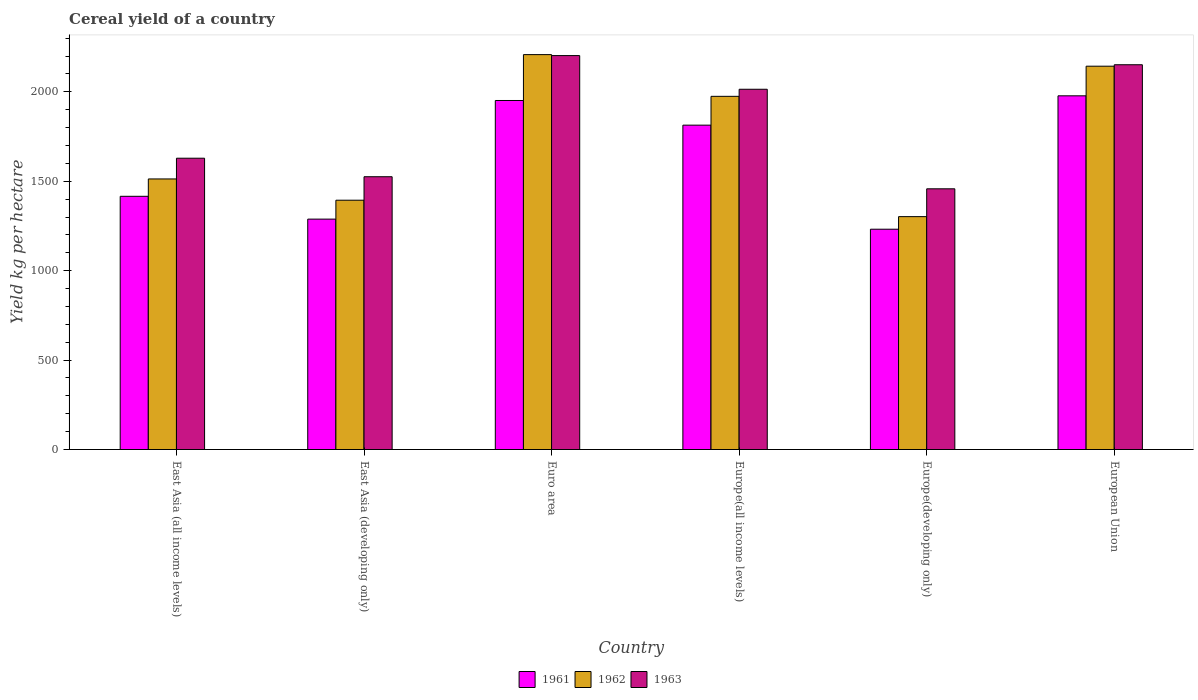How many groups of bars are there?
Provide a succinct answer. 6. How many bars are there on the 2nd tick from the right?
Make the answer very short. 3. What is the label of the 2nd group of bars from the left?
Ensure brevity in your answer.  East Asia (developing only). What is the total cereal yield in 1963 in East Asia (developing only)?
Offer a very short reply. 1525.26. Across all countries, what is the maximum total cereal yield in 1962?
Your answer should be very brief. 2207.97. Across all countries, what is the minimum total cereal yield in 1963?
Ensure brevity in your answer.  1457.68. In which country was the total cereal yield in 1963 minimum?
Provide a succinct answer. Europe(developing only). What is the total total cereal yield in 1962 in the graph?
Make the answer very short. 1.05e+04. What is the difference between the total cereal yield in 1961 in Europe(all income levels) and that in European Union?
Give a very brief answer. -163.96. What is the difference between the total cereal yield in 1961 in Euro area and the total cereal yield in 1963 in East Asia (developing only)?
Keep it short and to the point. 426.25. What is the average total cereal yield in 1962 per country?
Your answer should be compact. 1755.82. What is the difference between the total cereal yield of/in 1963 and total cereal yield of/in 1962 in East Asia (developing only)?
Provide a succinct answer. 131.32. In how many countries, is the total cereal yield in 1962 greater than 200 kg per hectare?
Your response must be concise. 6. What is the ratio of the total cereal yield in 1963 in East Asia (all income levels) to that in Europe(developing only)?
Your answer should be very brief. 1.12. Is the total cereal yield in 1963 in Euro area less than that in European Union?
Your answer should be compact. No. Is the difference between the total cereal yield in 1963 in East Asia (all income levels) and Europe(developing only) greater than the difference between the total cereal yield in 1962 in East Asia (all income levels) and Europe(developing only)?
Provide a short and direct response. No. What is the difference between the highest and the second highest total cereal yield in 1963?
Provide a succinct answer. 188.19. What is the difference between the highest and the lowest total cereal yield in 1961?
Keep it short and to the point. 745.86. Is the sum of the total cereal yield in 1962 in East Asia (all income levels) and Euro area greater than the maximum total cereal yield in 1961 across all countries?
Your answer should be compact. Yes. What does the 3rd bar from the left in Europe(all income levels) represents?
Offer a very short reply. 1963. How many bars are there?
Offer a terse response. 18. How many countries are there in the graph?
Offer a terse response. 6. Are the values on the major ticks of Y-axis written in scientific E-notation?
Make the answer very short. No. Does the graph contain any zero values?
Offer a terse response. No. Where does the legend appear in the graph?
Provide a short and direct response. Bottom center. How many legend labels are there?
Provide a short and direct response. 3. How are the legend labels stacked?
Keep it short and to the point. Horizontal. What is the title of the graph?
Your response must be concise. Cereal yield of a country. What is the label or title of the Y-axis?
Your answer should be compact. Yield kg per hectare. What is the Yield kg per hectare in 1961 in East Asia (all income levels)?
Ensure brevity in your answer.  1415.81. What is the Yield kg per hectare in 1962 in East Asia (all income levels)?
Offer a very short reply. 1512.87. What is the Yield kg per hectare of 1963 in East Asia (all income levels)?
Your response must be concise. 1628.8. What is the Yield kg per hectare of 1961 in East Asia (developing only)?
Make the answer very short. 1288.2. What is the Yield kg per hectare in 1962 in East Asia (developing only)?
Keep it short and to the point. 1393.94. What is the Yield kg per hectare of 1963 in East Asia (developing only)?
Provide a short and direct response. 1525.26. What is the Yield kg per hectare of 1961 in Euro area?
Your response must be concise. 1951.5. What is the Yield kg per hectare in 1962 in Euro area?
Offer a very short reply. 2207.97. What is the Yield kg per hectare in 1963 in Euro area?
Your answer should be very brief. 2202.53. What is the Yield kg per hectare of 1961 in Europe(all income levels)?
Your answer should be compact. 1813.66. What is the Yield kg per hectare of 1962 in Europe(all income levels)?
Make the answer very short. 1974.73. What is the Yield kg per hectare in 1963 in Europe(all income levels)?
Your answer should be compact. 2014.33. What is the Yield kg per hectare of 1961 in Europe(developing only)?
Offer a terse response. 1231.76. What is the Yield kg per hectare in 1962 in Europe(developing only)?
Keep it short and to the point. 1302.16. What is the Yield kg per hectare in 1963 in Europe(developing only)?
Make the answer very short. 1457.68. What is the Yield kg per hectare of 1961 in European Union?
Your response must be concise. 1977.62. What is the Yield kg per hectare in 1962 in European Union?
Your response must be concise. 2143.26. What is the Yield kg per hectare in 1963 in European Union?
Offer a very short reply. 2151.34. Across all countries, what is the maximum Yield kg per hectare in 1961?
Your answer should be very brief. 1977.62. Across all countries, what is the maximum Yield kg per hectare of 1962?
Provide a succinct answer. 2207.97. Across all countries, what is the maximum Yield kg per hectare of 1963?
Your answer should be compact. 2202.53. Across all countries, what is the minimum Yield kg per hectare of 1961?
Keep it short and to the point. 1231.76. Across all countries, what is the minimum Yield kg per hectare in 1962?
Give a very brief answer. 1302.16. Across all countries, what is the minimum Yield kg per hectare in 1963?
Provide a short and direct response. 1457.68. What is the total Yield kg per hectare in 1961 in the graph?
Offer a terse response. 9678.56. What is the total Yield kg per hectare in 1962 in the graph?
Ensure brevity in your answer.  1.05e+04. What is the total Yield kg per hectare in 1963 in the graph?
Provide a succinct answer. 1.10e+04. What is the difference between the Yield kg per hectare in 1961 in East Asia (all income levels) and that in East Asia (developing only)?
Provide a short and direct response. 127.62. What is the difference between the Yield kg per hectare of 1962 in East Asia (all income levels) and that in East Asia (developing only)?
Your response must be concise. 118.93. What is the difference between the Yield kg per hectare in 1963 in East Asia (all income levels) and that in East Asia (developing only)?
Provide a succinct answer. 103.54. What is the difference between the Yield kg per hectare of 1961 in East Asia (all income levels) and that in Euro area?
Keep it short and to the point. -535.69. What is the difference between the Yield kg per hectare of 1962 in East Asia (all income levels) and that in Euro area?
Keep it short and to the point. -695.09. What is the difference between the Yield kg per hectare of 1963 in East Asia (all income levels) and that in Euro area?
Offer a terse response. -573.73. What is the difference between the Yield kg per hectare in 1961 in East Asia (all income levels) and that in Europe(all income levels)?
Your answer should be compact. -397.85. What is the difference between the Yield kg per hectare of 1962 in East Asia (all income levels) and that in Europe(all income levels)?
Make the answer very short. -461.86. What is the difference between the Yield kg per hectare of 1963 in East Asia (all income levels) and that in Europe(all income levels)?
Keep it short and to the point. -385.53. What is the difference between the Yield kg per hectare in 1961 in East Asia (all income levels) and that in Europe(developing only)?
Provide a short and direct response. 184.05. What is the difference between the Yield kg per hectare of 1962 in East Asia (all income levels) and that in Europe(developing only)?
Keep it short and to the point. 210.71. What is the difference between the Yield kg per hectare of 1963 in East Asia (all income levels) and that in Europe(developing only)?
Offer a terse response. 171.12. What is the difference between the Yield kg per hectare in 1961 in East Asia (all income levels) and that in European Union?
Provide a succinct answer. -561.81. What is the difference between the Yield kg per hectare of 1962 in East Asia (all income levels) and that in European Union?
Offer a terse response. -630.39. What is the difference between the Yield kg per hectare of 1963 in East Asia (all income levels) and that in European Union?
Ensure brevity in your answer.  -522.54. What is the difference between the Yield kg per hectare of 1961 in East Asia (developing only) and that in Euro area?
Offer a very short reply. -663.31. What is the difference between the Yield kg per hectare of 1962 in East Asia (developing only) and that in Euro area?
Your answer should be compact. -814.03. What is the difference between the Yield kg per hectare in 1963 in East Asia (developing only) and that in Euro area?
Keep it short and to the point. -677.27. What is the difference between the Yield kg per hectare of 1961 in East Asia (developing only) and that in Europe(all income levels)?
Your answer should be compact. -525.46. What is the difference between the Yield kg per hectare of 1962 in East Asia (developing only) and that in Europe(all income levels)?
Provide a succinct answer. -580.8. What is the difference between the Yield kg per hectare in 1963 in East Asia (developing only) and that in Europe(all income levels)?
Make the answer very short. -489.08. What is the difference between the Yield kg per hectare of 1961 in East Asia (developing only) and that in Europe(developing only)?
Your response must be concise. 56.44. What is the difference between the Yield kg per hectare in 1962 in East Asia (developing only) and that in Europe(developing only)?
Provide a succinct answer. 91.78. What is the difference between the Yield kg per hectare in 1963 in East Asia (developing only) and that in Europe(developing only)?
Offer a terse response. 67.57. What is the difference between the Yield kg per hectare of 1961 in East Asia (developing only) and that in European Union?
Your answer should be compact. -689.42. What is the difference between the Yield kg per hectare of 1962 in East Asia (developing only) and that in European Union?
Your answer should be very brief. -749.32. What is the difference between the Yield kg per hectare in 1963 in East Asia (developing only) and that in European Union?
Provide a short and direct response. -626.09. What is the difference between the Yield kg per hectare of 1961 in Euro area and that in Europe(all income levels)?
Keep it short and to the point. 137.84. What is the difference between the Yield kg per hectare of 1962 in Euro area and that in Europe(all income levels)?
Make the answer very short. 233.23. What is the difference between the Yield kg per hectare in 1963 in Euro area and that in Europe(all income levels)?
Your answer should be compact. 188.19. What is the difference between the Yield kg per hectare in 1961 in Euro area and that in Europe(developing only)?
Offer a terse response. 719.74. What is the difference between the Yield kg per hectare in 1962 in Euro area and that in Europe(developing only)?
Offer a very short reply. 905.8. What is the difference between the Yield kg per hectare in 1963 in Euro area and that in Europe(developing only)?
Make the answer very short. 744.85. What is the difference between the Yield kg per hectare of 1961 in Euro area and that in European Union?
Provide a succinct answer. -26.11. What is the difference between the Yield kg per hectare in 1962 in Euro area and that in European Union?
Offer a terse response. 64.71. What is the difference between the Yield kg per hectare of 1963 in Euro area and that in European Union?
Provide a succinct answer. 51.19. What is the difference between the Yield kg per hectare of 1961 in Europe(all income levels) and that in Europe(developing only)?
Provide a short and direct response. 581.9. What is the difference between the Yield kg per hectare in 1962 in Europe(all income levels) and that in Europe(developing only)?
Your response must be concise. 672.57. What is the difference between the Yield kg per hectare in 1963 in Europe(all income levels) and that in Europe(developing only)?
Make the answer very short. 556.65. What is the difference between the Yield kg per hectare of 1961 in Europe(all income levels) and that in European Union?
Keep it short and to the point. -163.96. What is the difference between the Yield kg per hectare in 1962 in Europe(all income levels) and that in European Union?
Your answer should be very brief. -168.53. What is the difference between the Yield kg per hectare of 1963 in Europe(all income levels) and that in European Union?
Your response must be concise. -137.01. What is the difference between the Yield kg per hectare in 1961 in Europe(developing only) and that in European Union?
Your answer should be very brief. -745.86. What is the difference between the Yield kg per hectare in 1962 in Europe(developing only) and that in European Union?
Offer a very short reply. -841.1. What is the difference between the Yield kg per hectare in 1963 in Europe(developing only) and that in European Union?
Ensure brevity in your answer.  -693.66. What is the difference between the Yield kg per hectare of 1961 in East Asia (all income levels) and the Yield kg per hectare of 1962 in East Asia (developing only)?
Your response must be concise. 21.88. What is the difference between the Yield kg per hectare in 1961 in East Asia (all income levels) and the Yield kg per hectare in 1963 in East Asia (developing only)?
Your answer should be very brief. -109.44. What is the difference between the Yield kg per hectare of 1962 in East Asia (all income levels) and the Yield kg per hectare of 1963 in East Asia (developing only)?
Ensure brevity in your answer.  -12.38. What is the difference between the Yield kg per hectare of 1961 in East Asia (all income levels) and the Yield kg per hectare of 1962 in Euro area?
Provide a succinct answer. -792.15. What is the difference between the Yield kg per hectare of 1961 in East Asia (all income levels) and the Yield kg per hectare of 1963 in Euro area?
Keep it short and to the point. -786.71. What is the difference between the Yield kg per hectare in 1962 in East Asia (all income levels) and the Yield kg per hectare in 1963 in Euro area?
Your answer should be very brief. -689.65. What is the difference between the Yield kg per hectare of 1961 in East Asia (all income levels) and the Yield kg per hectare of 1962 in Europe(all income levels)?
Offer a very short reply. -558.92. What is the difference between the Yield kg per hectare in 1961 in East Asia (all income levels) and the Yield kg per hectare in 1963 in Europe(all income levels)?
Your response must be concise. -598.52. What is the difference between the Yield kg per hectare of 1962 in East Asia (all income levels) and the Yield kg per hectare of 1963 in Europe(all income levels)?
Offer a very short reply. -501.46. What is the difference between the Yield kg per hectare of 1961 in East Asia (all income levels) and the Yield kg per hectare of 1962 in Europe(developing only)?
Keep it short and to the point. 113.65. What is the difference between the Yield kg per hectare of 1961 in East Asia (all income levels) and the Yield kg per hectare of 1963 in Europe(developing only)?
Offer a very short reply. -41.87. What is the difference between the Yield kg per hectare in 1962 in East Asia (all income levels) and the Yield kg per hectare in 1963 in Europe(developing only)?
Provide a succinct answer. 55.19. What is the difference between the Yield kg per hectare of 1961 in East Asia (all income levels) and the Yield kg per hectare of 1962 in European Union?
Your response must be concise. -727.45. What is the difference between the Yield kg per hectare of 1961 in East Asia (all income levels) and the Yield kg per hectare of 1963 in European Union?
Provide a succinct answer. -735.53. What is the difference between the Yield kg per hectare in 1962 in East Asia (all income levels) and the Yield kg per hectare in 1963 in European Union?
Give a very brief answer. -638.47. What is the difference between the Yield kg per hectare of 1961 in East Asia (developing only) and the Yield kg per hectare of 1962 in Euro area?
Your response must be concise. -919.77. What is the difference between the Yield kg per hectare in 1961 in East Asia (developing only) and the Yield kg per hectare in 1963 in Euro area?
Provide a succinct answer. -914.33. What is the difference between the Yield kg per hectare of 1962 in East Asia (developing only) and the Yield kg per hectare of 1963 in Euro area?
Make the answer very short. -808.59. What is the difference between the Yield kg per hectare of 1961 in East Asia (developing only) and the Yield kg per hectare of 1962 in Europe(all income levels)?
Offer a terse response. -686.54. What is the difference between the Yield kg per hectare in 1961 in East Asia (developing only) and the Yield kg per hectare in 1963 in Europe(all income levels)?
Offer a terse response. -726.14. What is the difference between the Yield kg per hectare of 1962 in East Asia (developing only) and the Yield kg per hectare of 1963 in Europe(all income levels)?
Give a very brief answer. -620.4. What is the difference between the Yield kg per hectare in 1961 in East Asia (developing only) and the Yield kg per hectare in 1962 in Europe(developing only)?
Offer a very short reply. -13.96. What is the difference between the Yield kg per hectare in 1961 in East Asia (developing only) and the Yield kg per hectare in 1963 in Europe(developing only)?
Your response must be concise. -169.48. What is the difference between the Yield kg per hectare of 1962 in East Asia (developing only) and the Yield kg per hectare of 1963 in Europe(developing only)?
Give a very brief answer. -63.74. What is the difference between the Yield kg per hectare of 1961 in East Asia (developing only) and the Yield kg per hectare of 1962 in European Union?
Provide a short and direct response. -855.06. What is the difference between the Yield kg per hectare in 1961 in East Asia (developing only) and the Yield kg per hectare in 1963 in European Union?
Your response must be concise. -863.14. What is the difference between the Yield kg per hectare of 1962 in East Asia (developing only) and the Yield kg per hectare of 1963 in European Union?
Your response must be concise. -757.4. What is the difference between the Yield kg per hectare in 1961 in Euro area and the Yield kg per hectare in 1962 in Europe(all income levels)?
Provide a succinct answer. -23.23. What is the difference between the Yield kg per hectare of 1961 in Euro area and the Yield kg per hectare of 1963 in Europe(all income levels)?
Offer a terse response. -62.83. What is the difference between the Yield kg per hectare of 1962 in Euro area and the Yield kg per hectare of 1963 in Europe(all income levels)?
Ensure brevity in your answer.  193.63. What is the difference between the Yield kg per hectare of 1961 in Euro area and the Yield kg per hectare of 1962 in Europe(developing only)?
Keep it short and to the point. 649.34. What is the difference between the Yield kg per hectare of 1961 in Euro area and the Yield kg per hectare of 1963 in Europe(developing only)?
Offer a terse response. 493.82. What is the difference between the Yield kg per hectare in 1962 in Euro area and the Yield kg per hectare in 1963 in Europe(developing only)?
Give a very brief answer. 750.28. What is the difference between the Yield kg per hectare in 1961 in Euro area and the Yield kg per hectare in 1962 in European Union?
Provide a succinct answer. -191.75. What is the difference between the Yield kg per hectare in 1961 in Euro area and the Yield kg per hectare in 1963 in European Union?
Ensure brevity in your answer.  -199.84. What is the difference between the Yield kg per hectare in 1962 in Euro area and the Yield kg per hectare in 1963 in European Union?
Offer a very short reply. 56.63. What is the difference between the Yield kg per hectare in 1961 in Europe(all income levels) and the Yield kg per hectare in 1962 in Europe(developing only)?
Ensure brevity in your answer.  511.5. What is the difference between the Yield kg per hectare of 1961 in Europe(all income levels) and the Yield kg per hectare of 1963 in Europe(developing only)?
Give a very brief answer. 355.98. What is the difference between the Yield kg per hectare of 1962 in Europe(all income levels) and the Yield kg per hectare of 1963 in Europe(developing only)?
Offer a very short reply. 517.05. What is the difference between the Yield kg per hectare of 1961 in Europe(all income levels) and the Yield kg per hectare of 1962 in European Union?
Provide a short and direct response. -329.6. What is the difference between the Yield kg per hectare of 1961 in Europe(all income levels) and the Yield kg per hectare of 1963 in European Union?
Your response must be concise. -337.68. What is the difference between the Yield kg per hectare of 1962 in Europe(all income levels) and the Yield kg per hectare of 1963 in European Union?
Your answer should be compact. -176.61. What is the difference between the Yield kg per hectare of 1961 in Europe(developing only) and the Yield kg per hectare of 1962 in European Union?
Make the answer very short. -911.5. What is the difference between the Yield kg per hectare of 1961 in Europe(developing only) and the Yield kg per hectare of 1963 in European Union?
Give a very brief answer. -919.58. What is the difference between the Yield kg per hectare in 1962 in Europe(developing only) and the Yield kg per hectare in 1963 in European Union?
Your answer should be compact. -849.18. What is the average Yield kg per hectare in 1961 per country?
Provide a succinct answer. 1613.09. What is the average Yield kg per hectare in 1962 per country?
Offer a terse response. 1755.82. What is the average Yield kg per hectare of 1963 per country?
Ensure brevity in your answer.  1829.99. What is the difference between the Yield kg per hectare in 1961 and Yield kg per hectare in 1962 in East Asia (all income levels)?
Keep it short and to the point. -97.06. What is the difference between the Yield kg per hectare in 1961 and Yield kg per hectare in 1963 in East Asia (all income levels)?
Your response must be concise. -212.99. What is the difference between the Yield kg per hectare in 1962 and Yield kg per hectare in 1963 in East Asia (all income levels)?
Keep it short and to the point. -115.93. What is the difference between the Yield kg per hectare of 1961 and Yield kg per hectare of 1962 in East Asia (developing only)?
Offer a terse response. -105.74. What is the difference between the Yield kg per hectare of 1961 and Yield kg per hectare of 1963 in East Asia (developing only)?
Offer a very short reply. -237.06. What is the difference between the Yield kg per hectare of 1962 and Yield kg per hectare of 1963 in East Asia (developing only)?
Offer a terse response. -131.32. What is the difference between the Yield kg per hectare of 1961 and Yield kg per hectare of 1962 in Euro area?
Your response must be concise. -256.46. What is the difference between the Yield kg per hectare in 1961 and Yield kg per hectare in 1963 in Euro area?
Keep it short and to the point. -251.02. What is the difference between the Yield kg per hectare of 1962 and Yield kg per hectare of 1963 in Euro area?
Ensure brevity in your answer.  5.44. What is the difference between the Yield kg per hectare in 1961 and Yield kg per hectare in 1962 in Europe(all income levels)?
Your response must be concise. -161.07. What is the difference between the Yield kg per hectare in 1961 and Yield kg per hectare in 1963 in Europe(all income levels)?
Keep it short and to the point. -200.67. What is the difference between the Yield kg per hectare in 1962 and Yield kg per hectare in 1963 in Europe(all income levels)?
Keep it short and to the point. -39.6. What is the difference between the Yield kg per hectare in 1961 and Yield kg per hectare in 1962 in Europe(developing only)?
Offer a terse response. -70.4. What is the difference between the Yield kg per hectare in 1961 and Yield kg per hectare in 1963 in Europe(developing only)?
Your answer should be compact. -225.92. What is the difference between the Yield kg per hectare of 1962 and Yield kg per hectare of 1963 in Europe(developing only)?
Keep it short and to the point. -155.52. What is the difference between the Yield kg per hectare in 1961 and Yield kg per hectare in 1962 in European Union?
Provide a short and direct response. -165.64. What is the difference between the Yield kg per hectare in 1961 and Yield kg per hectare in 1963 in European Union?
Provide a succinct answer. -173.72. What is the difference between the Yield kg per hectare of 1962 and Yield kg per hectare of 1963 in European Union?
Give a very brief answer. -8.08. What is the ratio of the Yield kg per hectare in 1961 in East Asia (all income levels) to that in East Asia (developing only)?
Your answer should be very brief. 1.1. What is the ratio of the Yield kg per hectare in 1962 in East Asia (all income levels) to that in East Asia (developing only)?
Your answer should be compact. 1.09. What is the ratio of the Yield kg per hectare of 1963 in East Asia (all income levels) to that in East Asia (developing only)?
Your response must be concise. 1.07. What is the ratio of the Yield kg per hectare in 1961 in East Asia (all income levels) to that in Euro area?
Offer a terse response. 0.73. What is the ratio of the Yield kg per hectare in 1962 in East Asia (all income levels) to that in Euro area?
Provide a succinct answer. 0.69. What is the ratio of the Yield kg per hectare of 1963 in East Asia (all income levels) to that in Euro area?
Your response must be concise. 0.74. What is the ratio of the Yield kg per hectare of 1961 in East Asia (all income levels) to that in Europe(all income levels)?
Keep it short and to the point. 0.78. What is the ratio of the Yield kg per hectare in 1962 in East Asia (all income levels) to that in Europe(all income levels)?
Offer a terse response. 0.77. What is the ratio of the Yield kg per hectare of 1963 in East Asia (all income levels) to that in Europe(all income levels)?
Give a very brief answer. 0.81. What is the ratio of the Yield kg per hectare in 1961 in East Asia (all income levels) to that in Europe(developing only)?
Keep it short and to the point. 1.15. What is the ratio of the Yield kg per hectare of 1962 in East Asia (all income levels) to that in Europe(developing only)?
Provide a short and direct response. 1.16. What is the ratio of the Yield kg per hectare in 1963 in East Asia (all income levels) to that in Europe(developing only)?
Offer a very short reply. 1.12. What is the ratio of the Yield kg per hectare of 1961 in East Asia (all income levels) to that in European Union?
Your response must be concise. 0.72. What is the ratio of the Yield kg per hectare in 1962 in East Asia (all income levels) to that in European Union?
Give a very brief answer. 0.71. What is the ratio of the Yield kg per hectare of 1963 in East Asia (all income levels) to that in European Union?
Offer a very short reply. 0.76. What is the ratio of the Yield kg per hectare of 1961 in East Asia (developing only) to that in Euro area?
Give a very brief answer. 0.66. What is the ratio of the Yield kg per hectare in 1962 in East Asia (developing only) to that in Euro area?
Keep it short and to the point. 0.63. What is the ratio of the Yield kg per hectare in 1963 in East Asia (developing only) to that in Euro area?
Offer a very short reply. 0.69. What is the ratio of the Yield kg per hectare of 1961 in East Asia (developing only) to that in Europe(all income levels)?
Offer a terse response. 0.71. What is the ratio of the Yield kg per hectare in 1962 in East Asia (developing only) to that in Europe(all income levels)?
Offer a very short reply. 0.71. What is the ratio of the Yield kg per hectare in 1963 in East Asia (developing only) to that in Europe(all income levels)?
Offer a very short reply. 0.76. What is the ratio of the Yield kg per hectare of 1961 in East Asia (developing only) to that in Europe(developing only)?
Your response must be concise. 1.05. What is the ratio of the Yield kg per hectare in 1962 in East Asia (developing only) to that in Europe(developing only)?
Offer a very short reply. 1.07. What is the ratio of the Yield kg per hectare in 1963 in East Asia (developing only) to that in Europe(developing only)?
Provide a short and direct response. 1.05. What is the ratio of the Yield kg per hectare of 1961 in East Asia (developing only) to that in European Union?
Give a very brief answer. 0.65. What is the ratio of the Yield kg per hectare of 1962 in East Asia (developing only) to that in European Union?
Provide a succinct answer. 0.65. What is the ratio of the Yield kg per hectare of 1963 in East Asia (developing only) to that in European Union?
Make the answer very short. 0.71. What is the ratio of the Yield kg per hectare of 1961 in Euro area to that in Europe(all income levels)?
Your answer should be very brief. 1.08. What is the ratio of the Yield kg per hectare in 1962 in Euro area to that in Europe(all income levels)?
Provide a succinct answer. 1.12. What is the ratio of the Yield kg per hectare in 1963 in Euro area to that in Europe(all income levels)?
Your answer should be very brief. 1.09. What is the ratio of the Yield kg per hectare of 1961 in Euro area to that in Europe(developing only)?
Offer a terse response. 1.58. What is the ratio of the Yield kg per hectare in 1962 in Euro area to that in Europe(developing only)?
Provide a succinct answer. 1.7. What is the ratio of the Yield kg per hectare in 1963 in Euro area to that in Europe(developing only)?
Your answer should be very brief. 1.51. What is the ratio of the Yield kg per hectare of 1962 in Euro area to that in European Union?
Your response must be concise. 1.03. What is the ratio of the Yield kg per hectare in 1963 in Euro area to that in European Union?
Keep it short and to the point. 1.02. What is the ratio of the Yield kg per hectare of 1961 in Europe(all income levels) to that in Europe(developing only)?
Keep it short and to the point. 1.47. What is the ratio of the Yield kg per hectare of 1962 in Europe(all income levels) to that in Europe(developing only)?
Keep it short and to the point. 1.52. What is the ratio of the Yield kg per hectare of 1963 in Europe(all income levels) to that in Europe(developing only)?
Make the answer very short. 1.38. What is the ratio of the Yield kg per hectare of 1961 in Europe(all income levels) to that in European Union?
Give a very brief answer. 0.92. What is the ratio of the Yield kg per hectare of 1962 in Europe(all income levels) to that in European Union?
Your answer should be compact. 0.92. What is the ratio of the Yield kg per hectare of 1963 in Europe(all income levels) to that in European Union?
Give a very brief answer. 0.94. What is the ratio of the Yield kg per hectare in 1961 in Europe(developing only) to that in European Union?
Provide a short and direct response. 0.62. What is the ratio of the Yield kg per hectare of 1962 in Europe(developing only) to that in European Union?
Offer a terse response. 0.61. What is the ratio of the Yield kg per hectare in 1963 in Europe(developing only) to that in European Union?
Offer a terse response. 0.68. What is the difference between the highest and the second highest Yield kg per hectare in 1961?
Your answer should be very brief. 26.11. What is the difference between the highest and the second highest Yield kg per hectare of 1962?
Your answer should be very brief. 64.71. What is the difference between the highest and the second highest Yield kg per hectare of 1963?
Provide a succinct answer. 51.19. What is the difference between the highest and the lowest Yield kg per hectare in 1961?
Make the answer very short. 745.86. What is the difference between the highest and the lowest Yield kg per hectare in 1962?
Your answer should be very brief. 905.8. What is the difference between the highest and the lowest Yield kg per hectare of 1963?
Give a very brief answer. 744.85. 